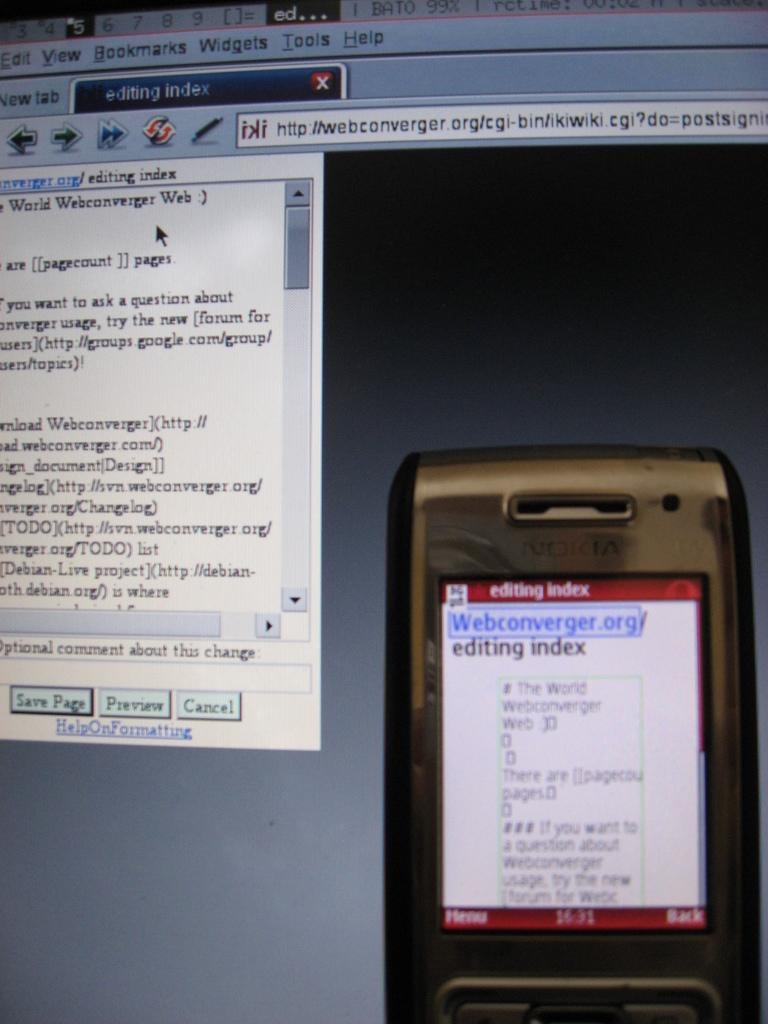<image>
Provide a brief description of the given image. The device is used for editing with a tool call webconverger. 